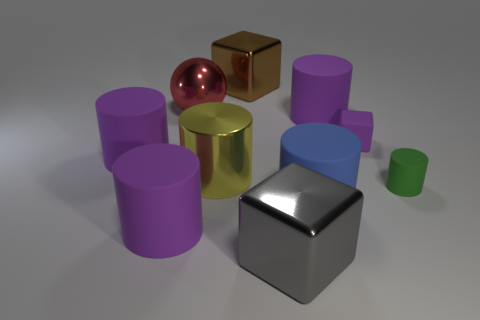Do the cube that is behind the large metal ball and the shiny cube that is in front of the large shiny cylinder have the same size?
Your answer should be very brief. Yes. What number of other objects are there of the same size as the green cylinder?
Make the answer very short. 1. There is a cube right of the shiny object in front of the green matte cylinder; is there a large purple object that is right of it?
Provide a succinct answer. No. Is there any other thing that is the same color as the rubber block?
Your response must be concise. Yes. There is a purple rubber cylinder behind the tiny purple matte thing; what size is it?
Give a very brief answer. Large. What is the size of the matte cylinder that is on the left side of the purple cylinder that is in front of the tiny rubber cylinder on the right side of the blue cylinder?
Ensure brevity in your answer.  Large. What color is the small thing to the left of the green cylinder that is to the right of the gray block?
Keep it short and to the point. Purple. What is the material of the big blue object that is the same shape as the green object?
Give a very brief answer. Rubber. Is there any other thing that is the same material as the big gray object?
Offer a very short reply. Yes. Are there any tiny green rubber cylinders on the right side of the small green rubber cylinder?
Provide a short and direct response. No. 